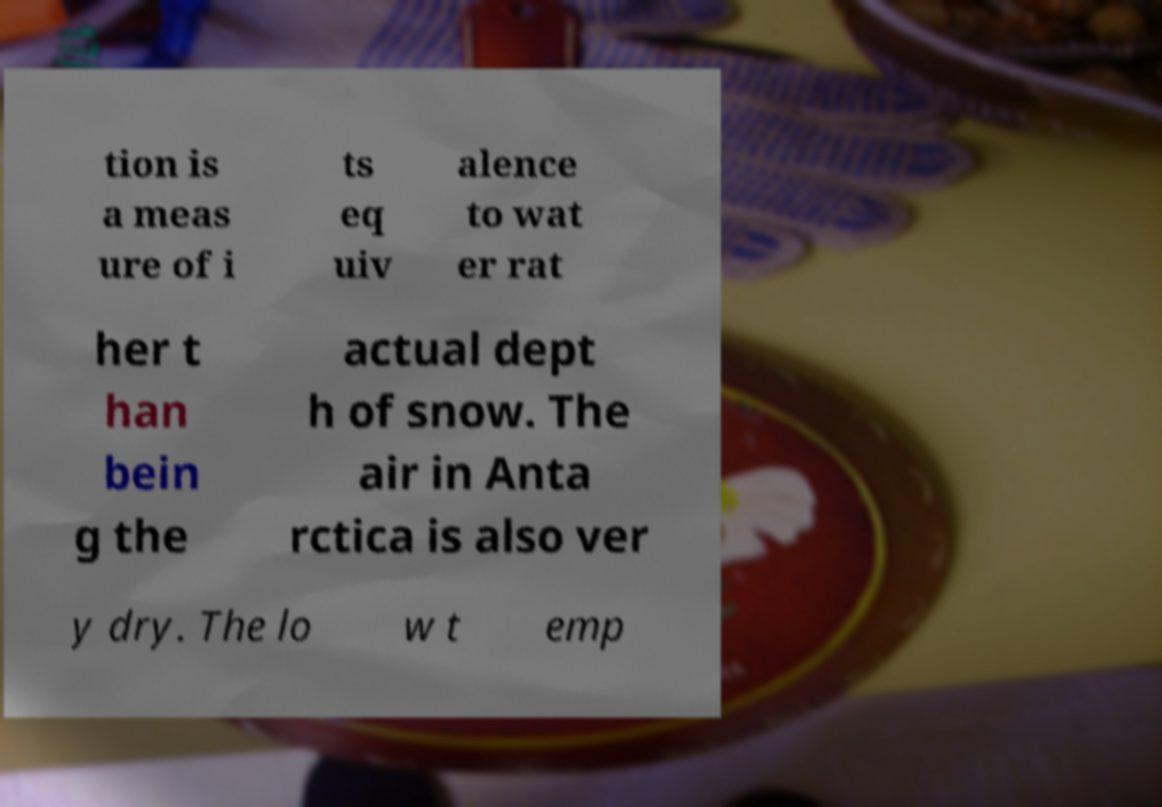For documentation purposes, I need the text within this image transcribed. Could you provide that? tion is a meas ure of i ts eq uiv alence to wat er rat her t han bein g the actual dept h of snow. The air in Anta rctica is also ver y dry. The lo w t emp 